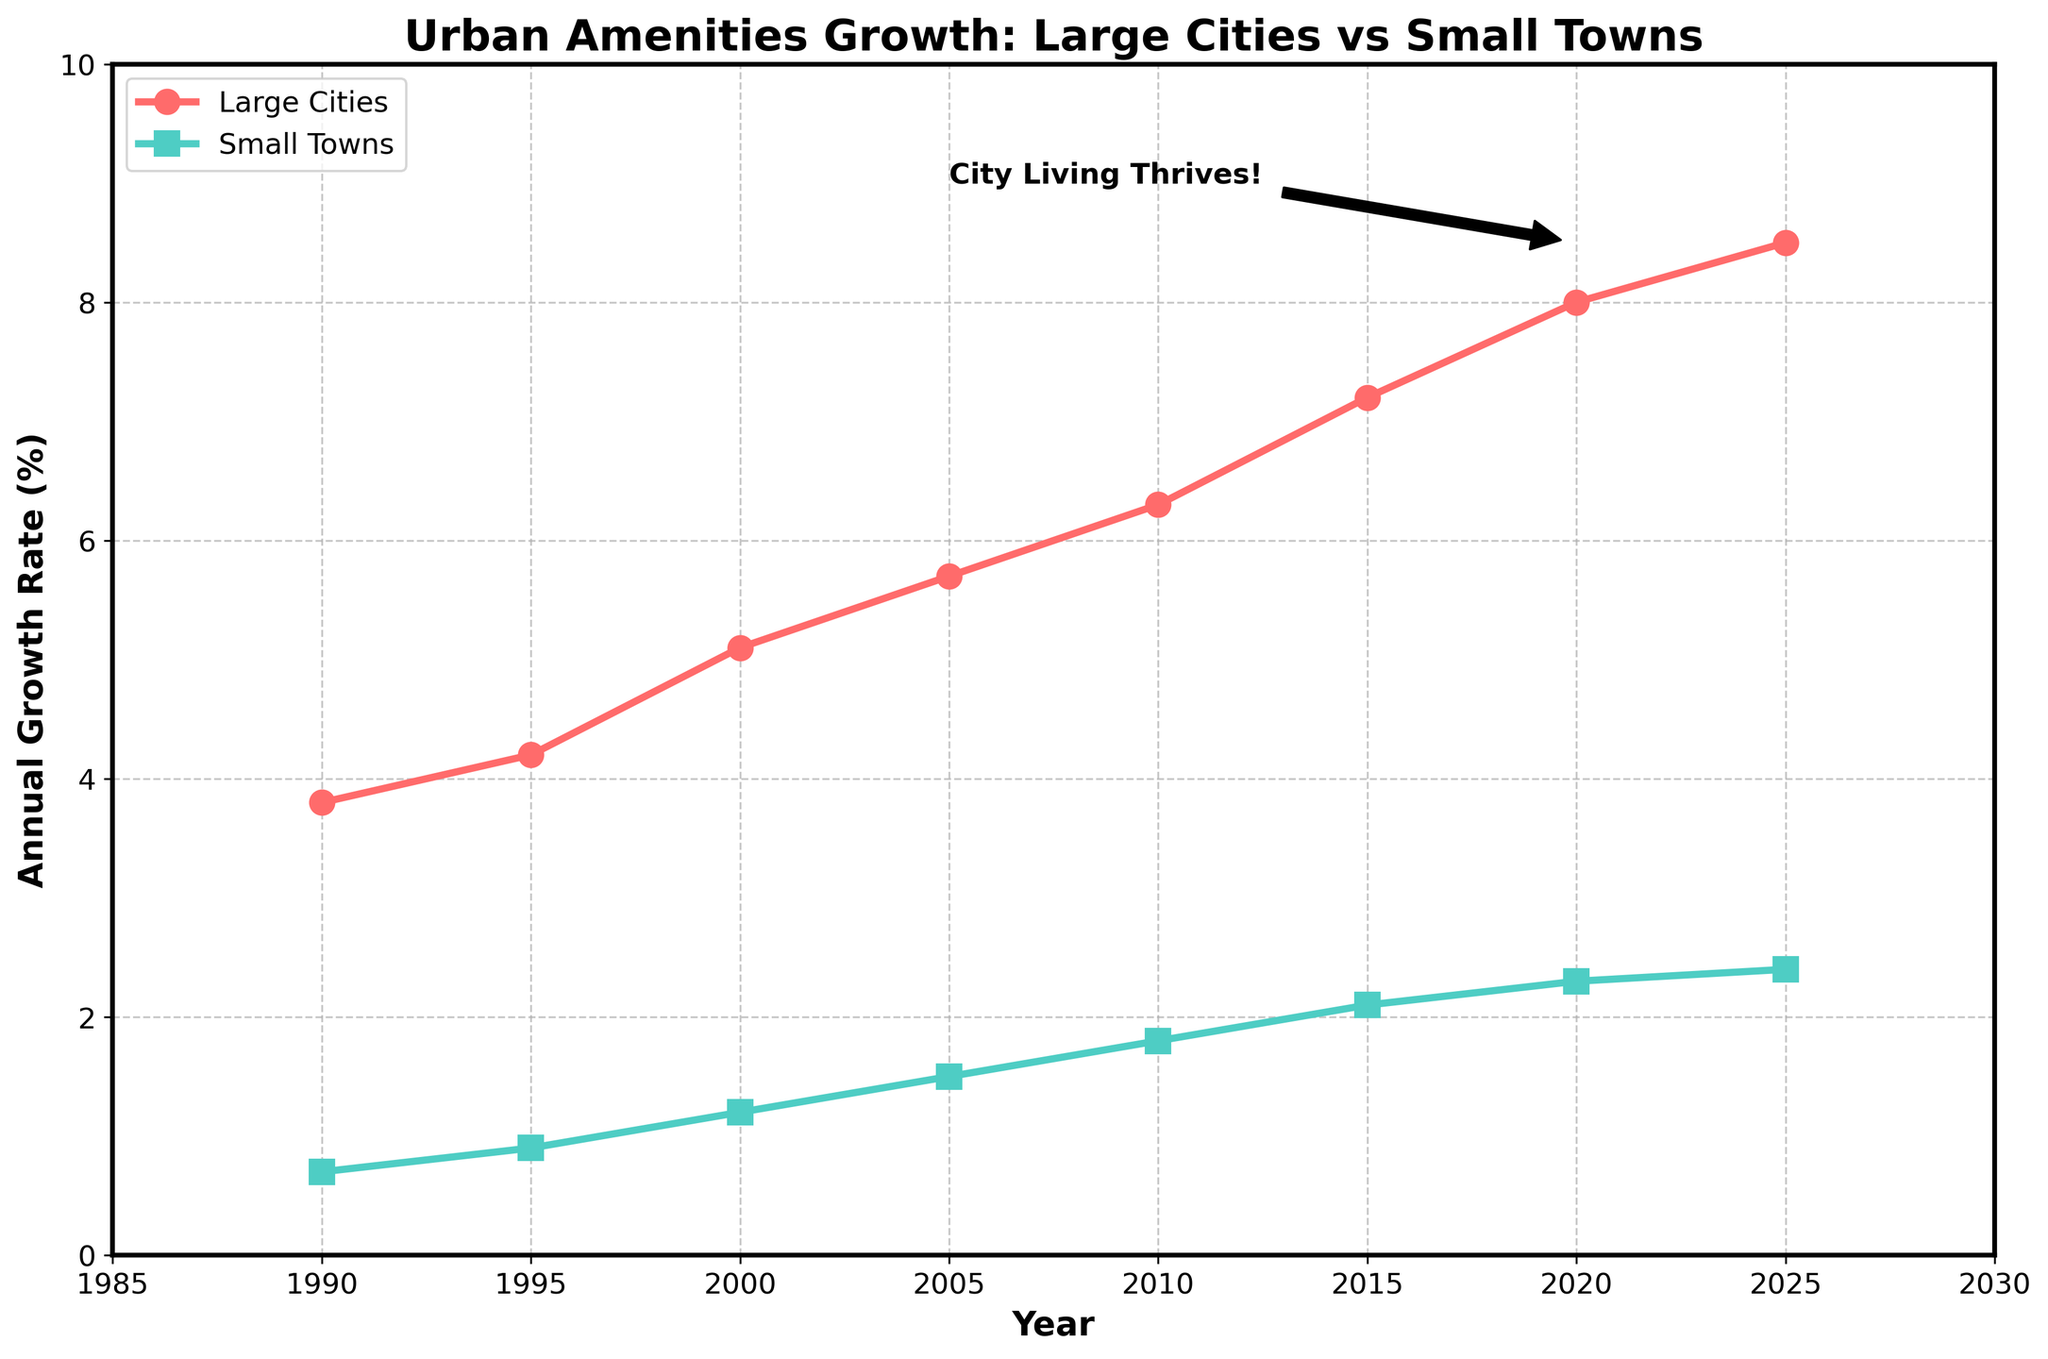What's the growth rate difference between large cities and small towns in 2000? To find the difference in growth rate, subtract the small towns' growth rate from the large cities' growth rate for the year 2000. So, \(5.1 - 1.2 = 3.9\).
Answer: 3.9% How many times did the growth rate in large cities surpass that of small towns in 2010? Divide the growth rate of large cities by the growth rate of small towns in 2010. So, \(6.3 / 1.8 \approx 3.5\).
Answer: 3.5 times Which type of area had the higher growth rate in 2005, and by how much? Compare the growth rates of large cities and small towns in 2005. Large cities had a growth rate of 5.7%, while small towns had a growth rate of 1.5%, making the difference \(5.7 - 1.5 = 4.2\).
Answer: Large cities by 4.2% What is the average growth rate of large cities between 1990 and 2025? First, sum up the growth rates for large cities over all given years: (3.8 + 4.2 + 5.1 + 5.7 + 6.3 + 7.2 + 8.0 + 8.5). Then divide by the number of years: \(48.8 / 8 = 6.1\).
Answer: 6.1% By how much did the growth rate in large cities increase from 1990 to 2010? Subtract the 1990 growth rate from the 2010 growth rate for large cities: \(6.3 - 3.8 = 2.5\).
Answer: 2.5% In which year did large cities see the sharpest rate increase? To determine this, look for the largest year-over-year increase in growth rates for large cities. From 2000 to 2005, the increase was \(5.7-5.1 = 0.6\). From 2005 to 2010, the increase was \(6.3-5.7 = 0.6\). The largest increase is observed from 1995 to 2000 with \(5.1-4.2 = 0.9\).
Answer: 1995 to 2000 By what percentage did small towns' growth rate change from 1990 to 1995? Calculate the percentage change using \(\frac{0.9 - 0.7}{0.7} \times 100 \approx 28.57\%\).
Answer: 28.57% What annotation is placed in the plot, and what does it indicate? There's an annotation "City Living Thrives!" near 2020 pointing to about a growth rate of 8.5% for large cities, indicating that city amenities are thriving compared to small towns.
Answer: City Living Thrives! indicating growth in large cities How much more was the growth rate increase in large cities compared to small towns from 2015 to 2020? Calculate the difference in growth rate increases for large cities and small towns: (8.0 - 7.2) - (2.3 - 2.1) = 0.8 - 0.2 = 0.6.
Answer: 0.6% What are the colors used to represent large cities and small towns? Identify the colors of the lines in the chart: large cities are represented by red, and small towns are represented by green.
Answer: Red for large cities, green for small towns 